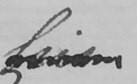What is written in this line of handwriting? his 